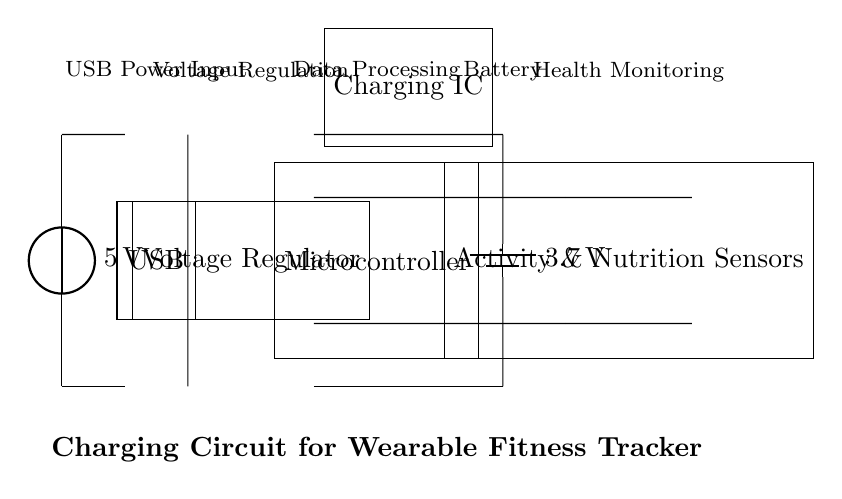What is the voltage of the power source? The voltage of the power source is specified directly in the circuit diagram as 5V. This is indicated near the voltage source component labeled as USB.
Answer: 5V What components connect to the battery? The components that connect to the battery are the charging IC and the microcontroller. You can see that the charging IC has direct connections to the battery terminals, as well as connections that lead to the microcontroller.
Answer: Charging IC and microcontroller What is the purpose of the voltage regulator? The voltage regulator's purpose is to ensure that the voltage supplied to the microcontroller and other components is stable and appropriate for their operation. It is essential for converting the 5V input from USB to a usable voltage level for the microcontroller and other devices.
Answer: Voltage stability How many sensors are present in this circuit? The circuit includes one set of sensors for activity and nutrition monitoring. The diagram shows these sensors clearly labeled near the output connections.
Answer: One set What is the output voltage of the battery? The output voltage of the battery is indicated in the diagram as 3.7V, which is directly shown next to the battery component.
Answer: 3.7V How does the microcontroller interact with the sensors? The microcontroller receives data from the sensors through direct connections as illustrated in the diagram. The connections from the microcontroller to the sensors indicate that it processes the data collected for health monitoring.
Answer: Data processing What function does the charging IC serve? The charging IC is responsible for managing the charging process of the battery, ensuring that it charges efficiently and safely within its specified voltage and current limits.
Answer: Battery charging management 